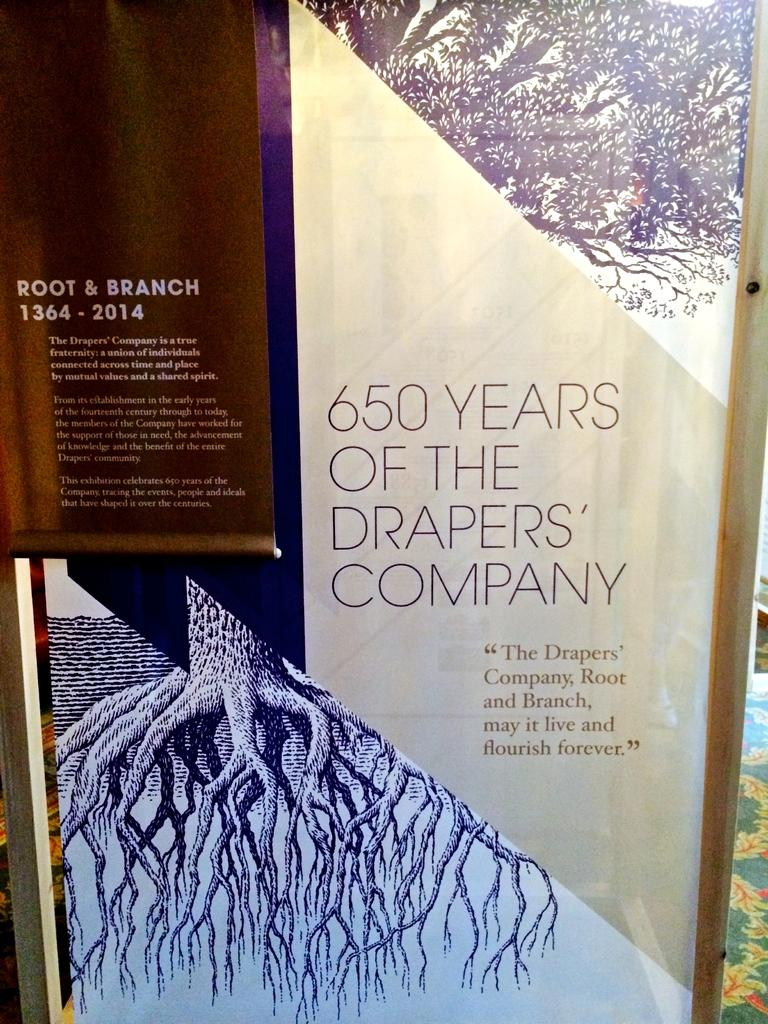<image>
Render a clear and concise summary of the photo. A poster on which is written "650 Years of the Drapers Company". 